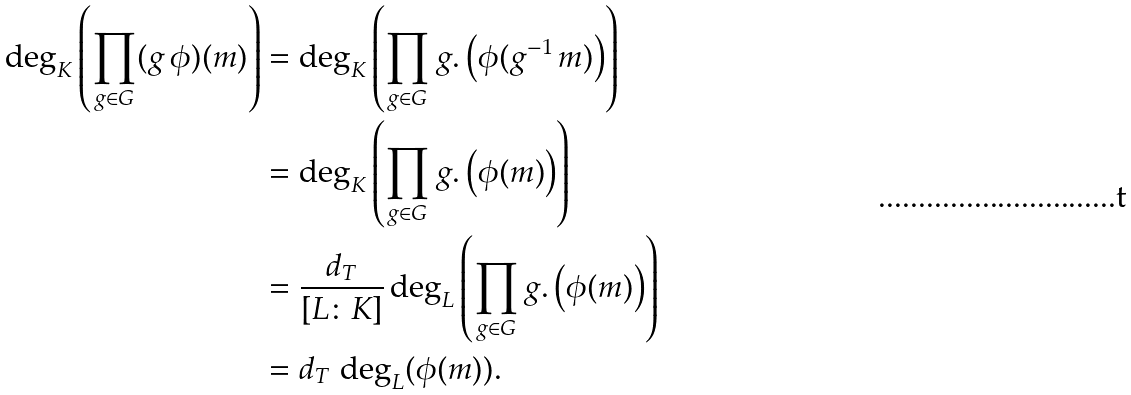Convert formula to latex. <formula><loc_0><loc_0><loc_500><loc_500>\deg _ { K } \left ( \prod _ { g \in G } ( g \, \phi ) ( m ) \right ) & = \deg _ { K } \left ( \prod _ { g \in G } g . \left ( \phi ( g ^ { - 1 } \, m ) \right ) \right ) \\ & = \deg _ { K } \left ( \prod _ { g \in G } g . \left ( \phi ( m ) \right ) \right ) \\ & = \frac { d _ { T } } { [ L \colon K ] } \deg _ { L } \left ( \prod _ { g \in G } g . \left ( \phi ( m ) \right ) \right ) \\ & = d _ { T } \, \deg _ { L } ( \phi ( m ) ) .</formula> 